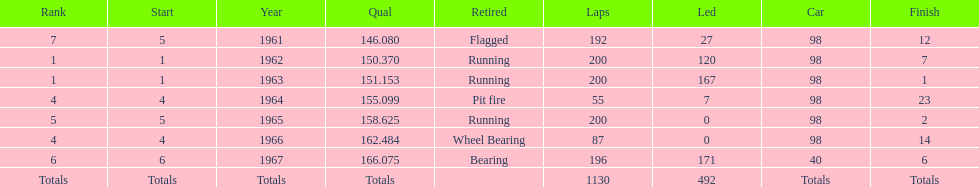How many consecutive years did parnelli place in the top 5? 5. 